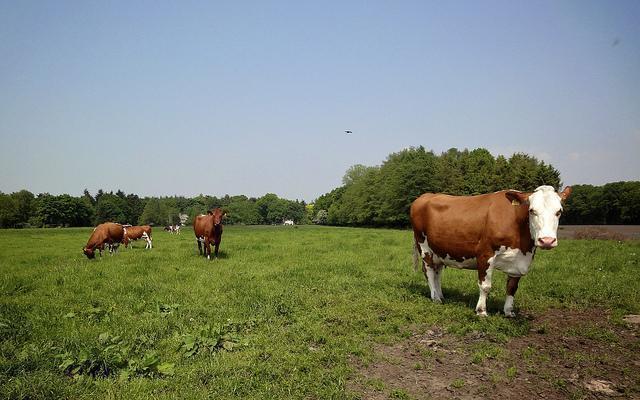How many cows are looking at the camera?
Make your selection from the four choices given to correctly answer the question.
Options: One, four, two, three. Two. 